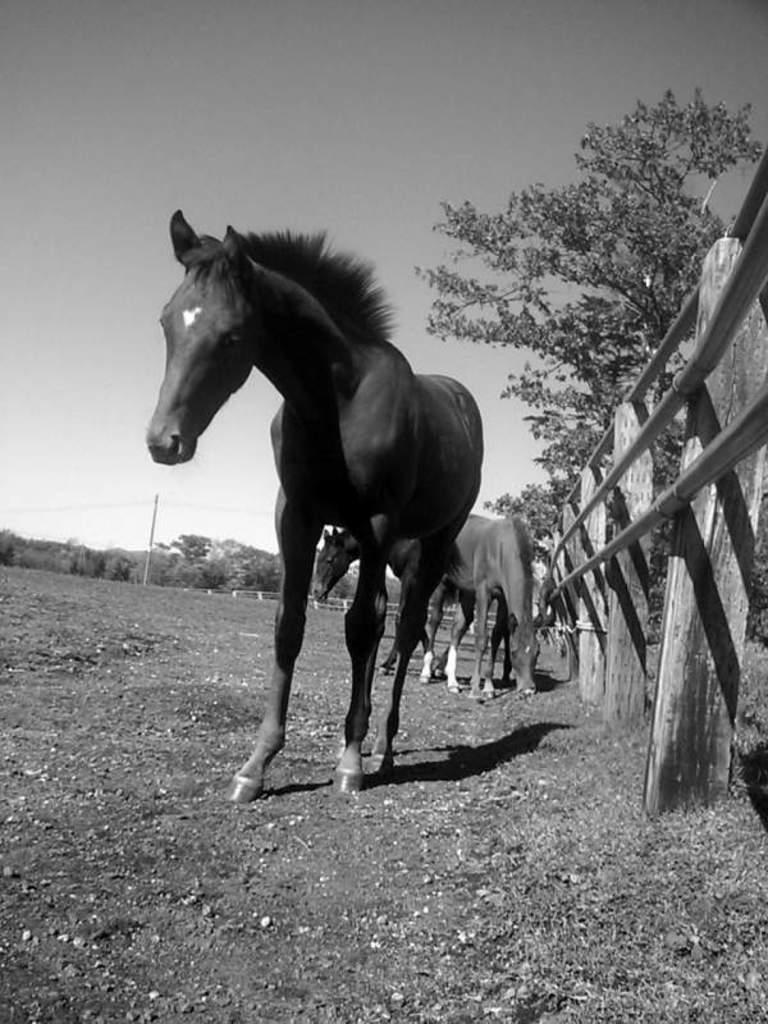What animals are present on the ground in the image? There are horses on the ground in the image. What can be seen on the right side of the image? There is fencing on the right side of the image. What type of vegetation is visible in the background of the image? There are trees in the background of the image. What other object can be seen in the background of the image? There is a pole in the background of the image. What part of the natural environment is visible in the image? The sky is visible in the background of the image. What type of pickle is being used to cut the fencing in the image? There is no pickle or scissors present in the image, and therefore no such activity can be observed. 